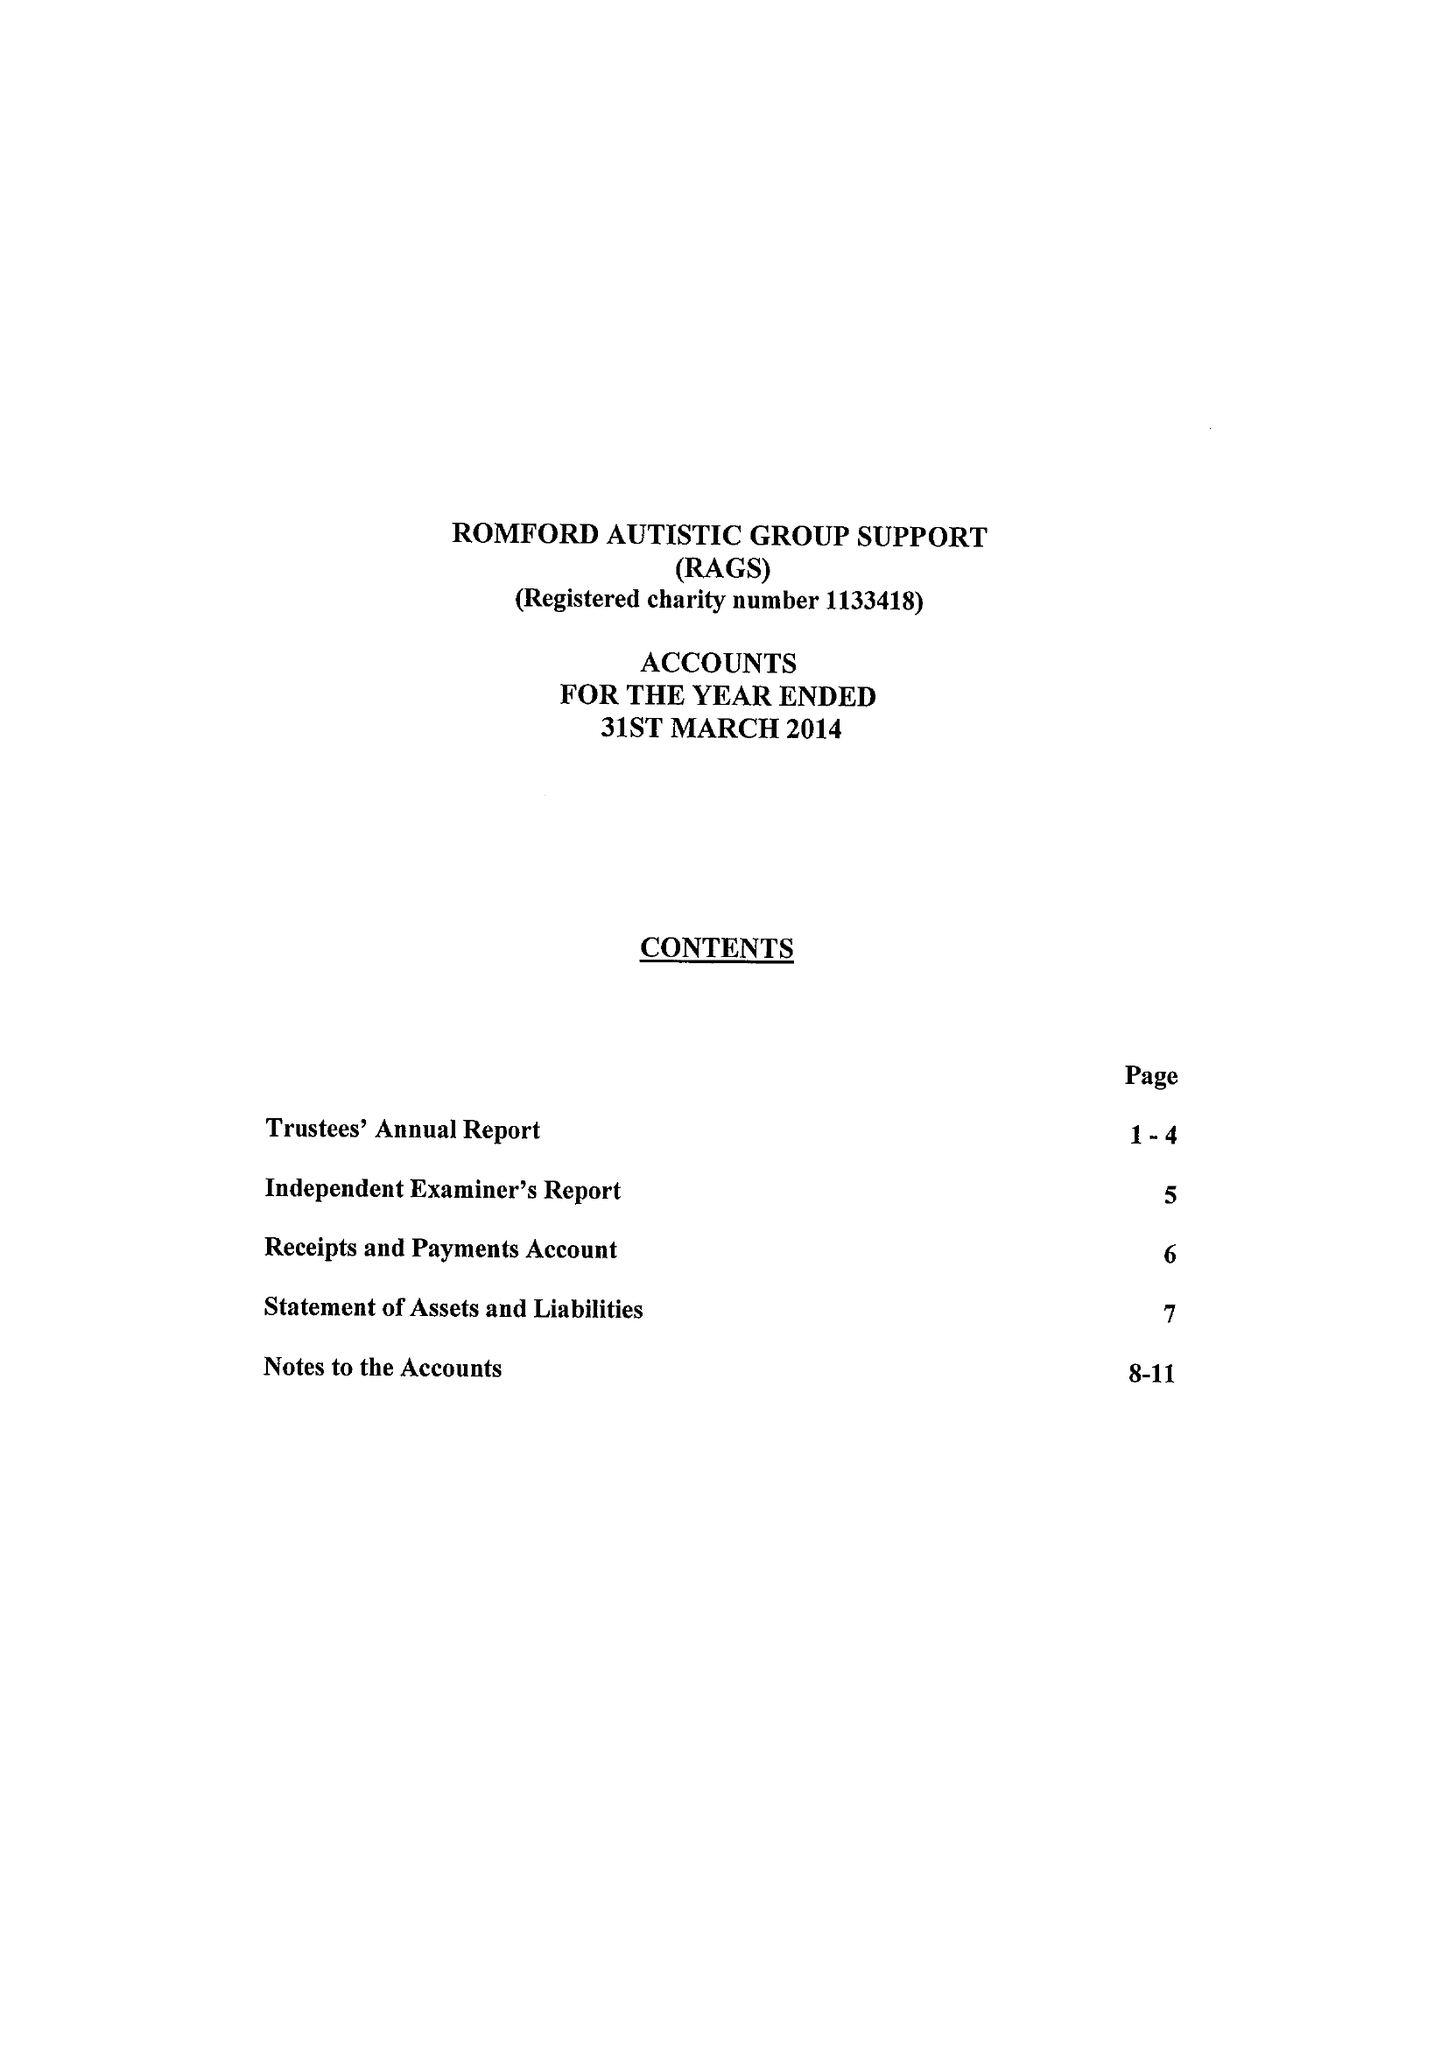What is the value for the address__post_town?
Answer the question using a single word or phrase. ROMFORD 